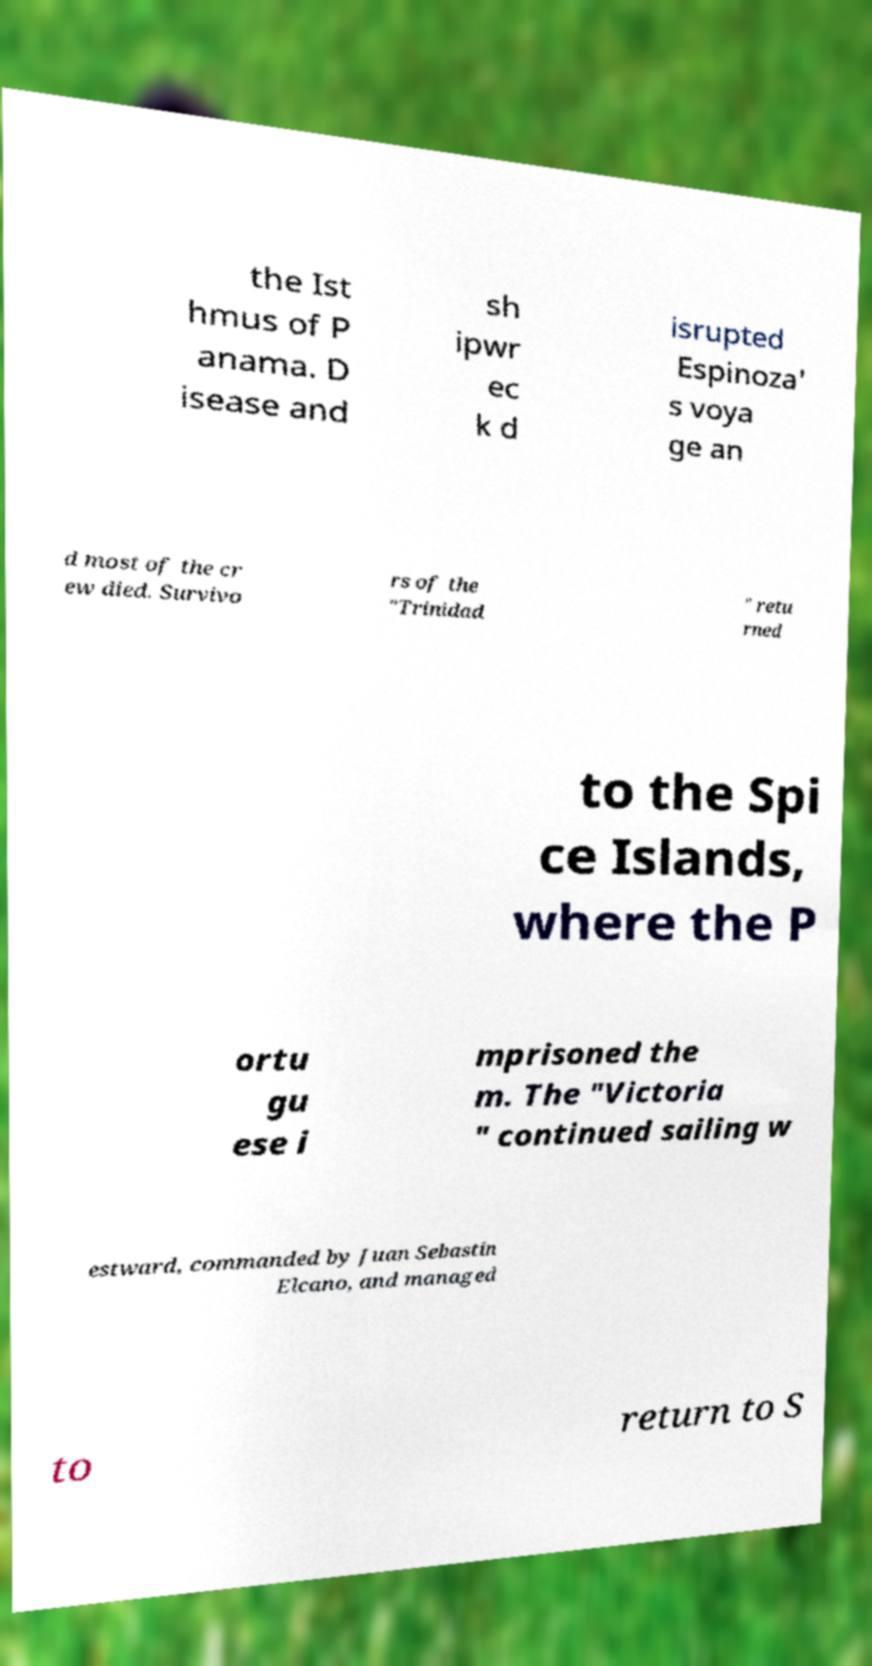Could you extract and type out the text from this image? the Ist hmus of P anama. D isease and sh ipwr ec k d isrupted Espinoza' s voya ge an d most of the cr ew died. Survivo rs of the "Trinidad " retu rned to the Spi ce Islands, where the P ortu gu ese i mprisoned the m. The "Victoria " continued sailing w estward, commanded by Juan Sebastin Elcano, and managed to return to S 